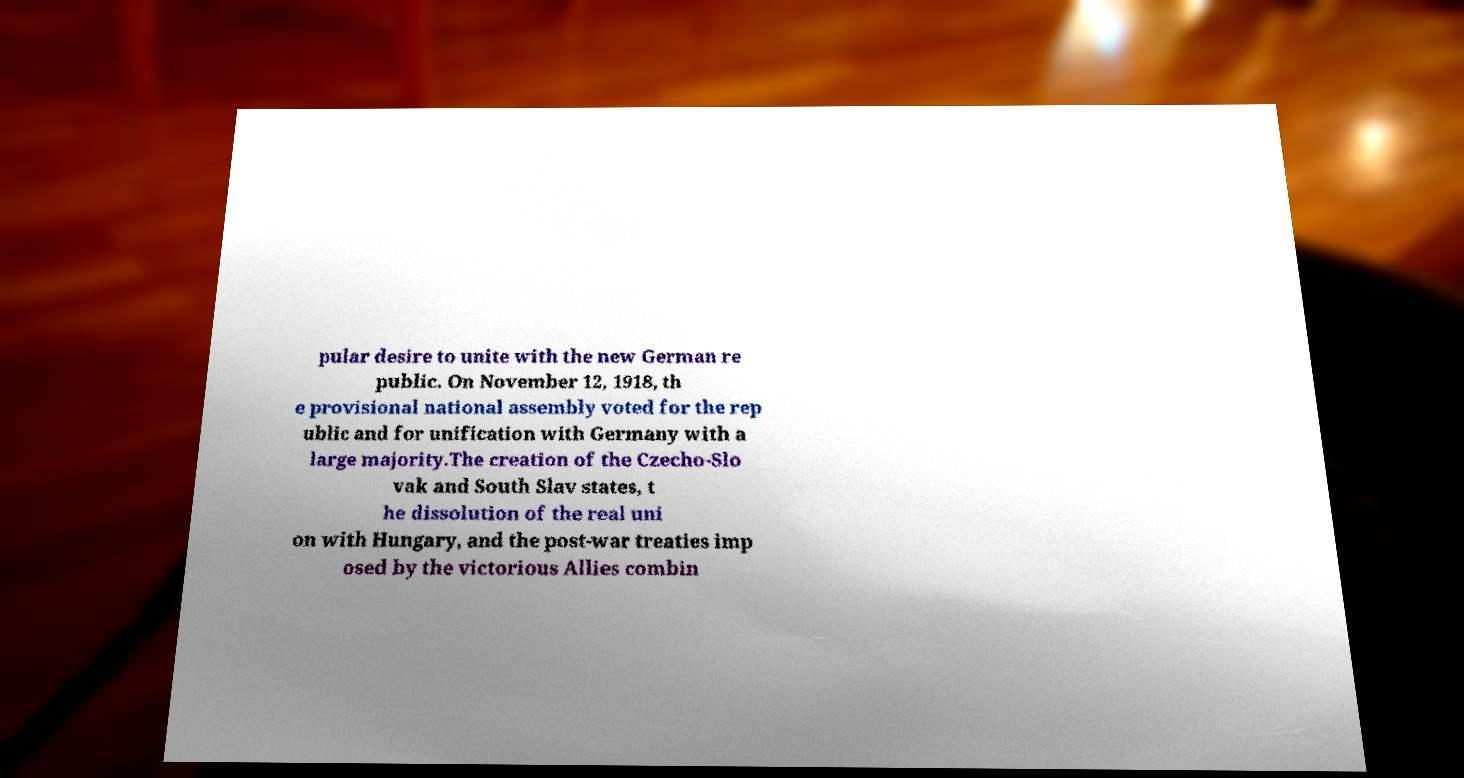Can you read and provide the text displayed in the image?This photo seems to have some interesting text. Can you extract and type it out for me? pular desire to unite with the new German re public. On November 12, 1918, th e provisional national assembly voted for the rep ublic and for unification with Germany with a large majority.The creation of the Czecho-Slo vak and South Slav states, t he dissolution of the real uni on with Hungary, and the post-war treaties imp osed by the victorious Allies combin 